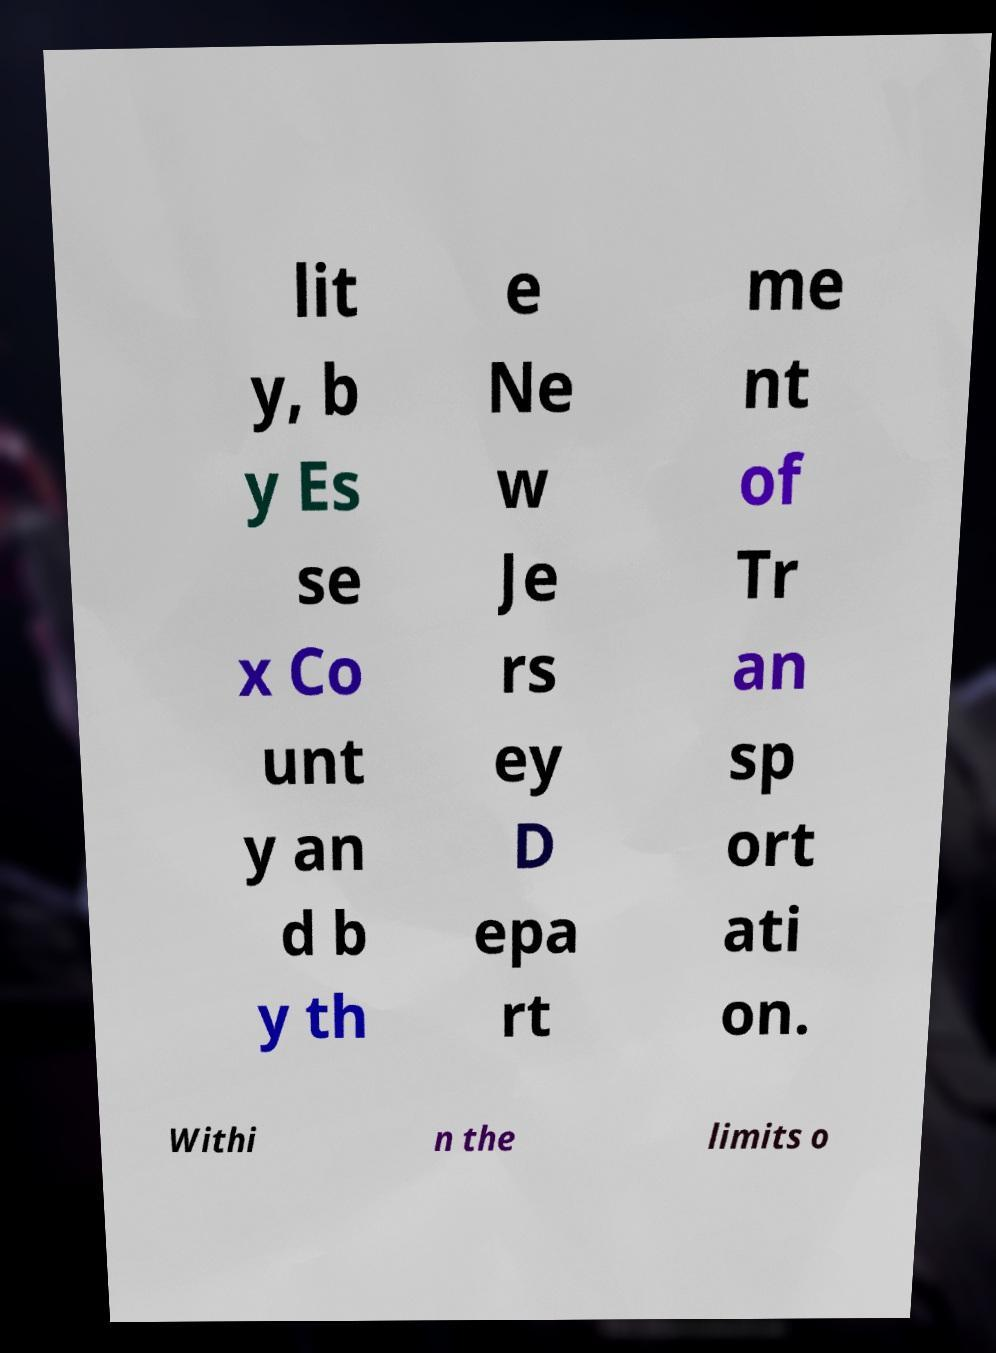Could you assist in decoding the text presented in this image and type it out clearly? lit y, b y Es se x Co unt y an d b y th e Ne w Je rs ey D epa rt me nt of Tr an sp ort ati on. Withi n the limits o 